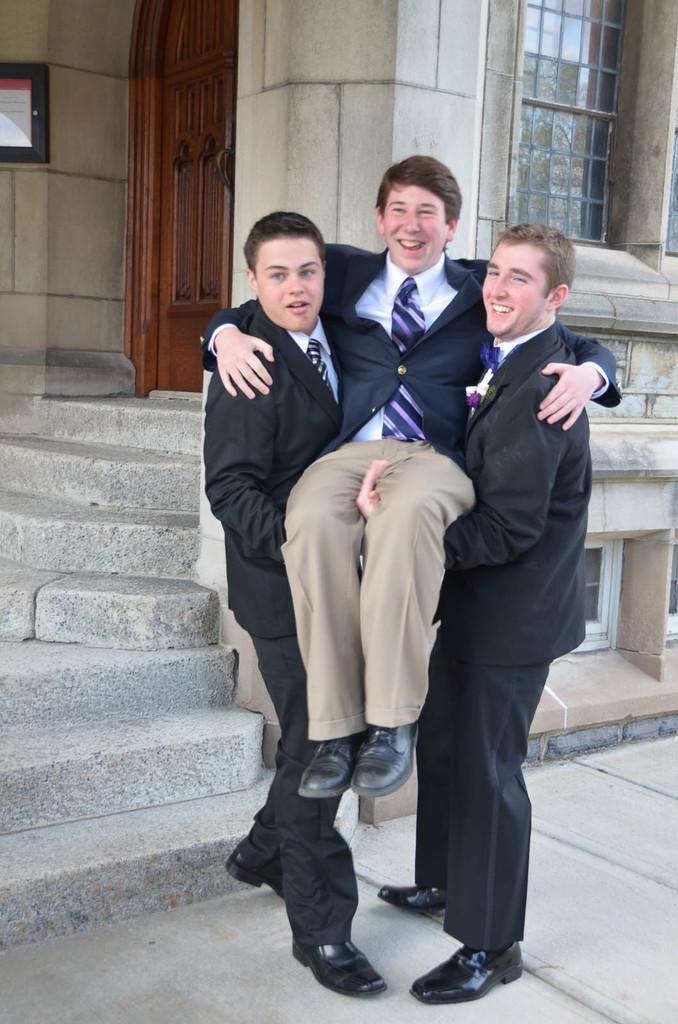In one or two sentences, can you explain what this image depicts? In this image, there are a few people. We can see the ground. We can see some stairs and the wall with some windows. We can also see a door and a board on the left. 